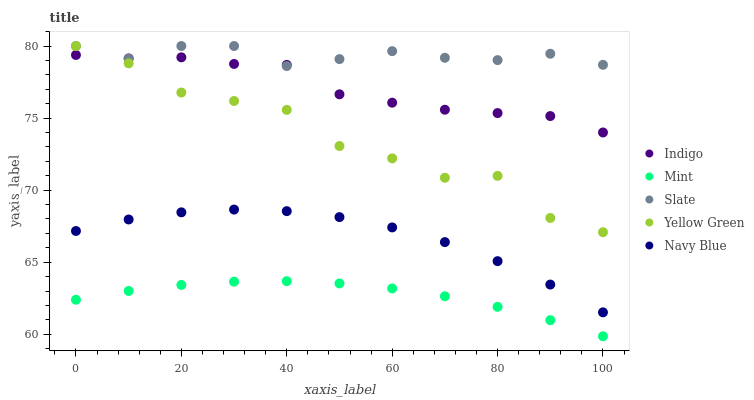Does Mint have the minimum area under the curve?
Answer yes or no. Yes. Does Slate have the maximum area under the curve?
Answer yes or no. Yes. Does Indigo have the minimum area under the curve?
Answer yes or no. No. Does Indigo have the maximum area under the curve?
Answer yes or no. No. Is Mint the smoothest?
Answer yes or no. Yes. Is Yellow Green the roughest?
Answer yes or no. Yes. Is Slate the smoothest?
Answer yes or no. No. Is Slate the roughest?
Answer yes or no. No. Does Mint have the lowest value?
Answer yes or no. Yes. Does Indigo have the lowest value?
Answer yes or no. No. Does Yellow Green have the highest value?
Answer yes or no. Yes. Does Indigo have the highest value?
Answer yes or no. No. Is Navy Blue less than Slate?
Answer yes or no. Yes. Is Yellow Green greater than Mint?
Answer yes or no. Yes. Does Indigo intersect Yellow Green?
Answer yes or no. Yes. Is Indigo less than Yellow Green?
Answer yes or no. No. Is Indigo greater than Yellow Green?
Answer yes or no. No. Does Navy Blue intersect Slate?
Answer yes or no. No. 